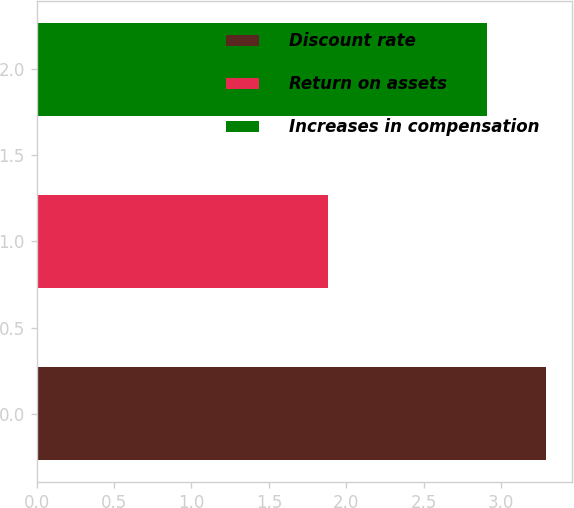Convert chart. <chart><loc_0><loc_0><loc_500><loc_500><bar_chart><fcel>Discount rate<fcel>Return on assets<fcel>Increases in compensation<nl><fcel>3.29<fcel>1.88<fcel>2.91<nl></chart> 